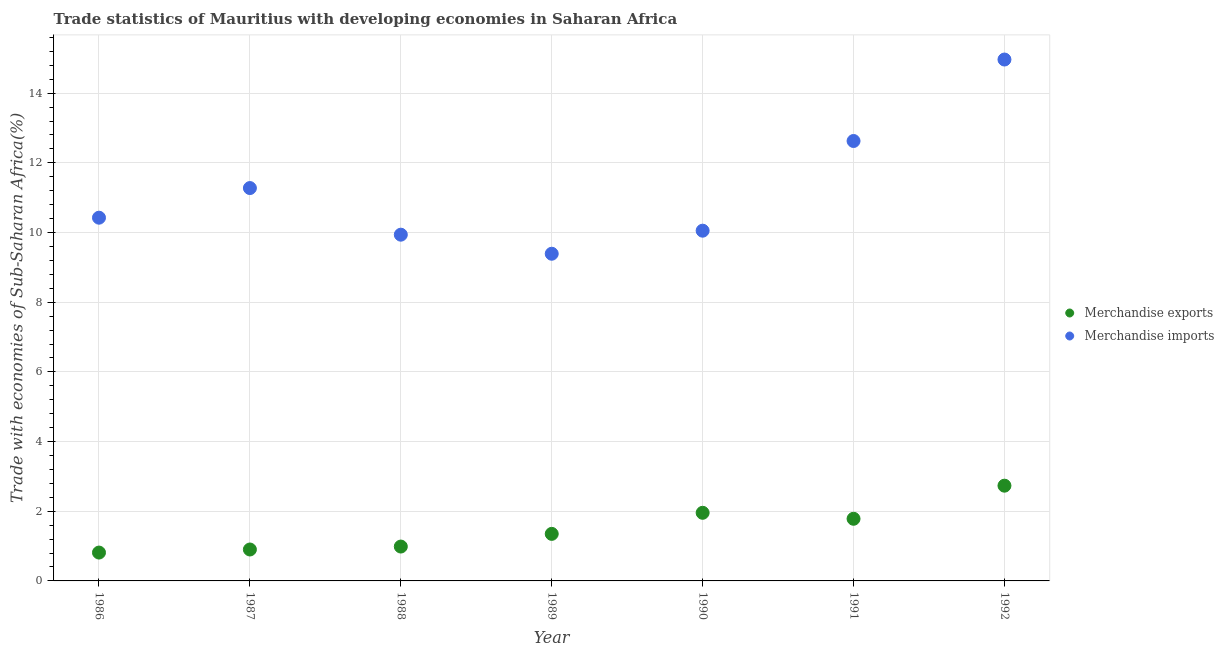How many different coloured dotlines are there?
Offer a very short reply. 2. What is the merchandise imports in 1990?
Ensure brevity in your answer.  10.05. Across all years, what is the maximum merchandise imports?
Offer a terse response. 14.97. Across all years, what is the minimum merchandise imports?
Make the answer very short. 9.39. In which year was the merchandise exports maximum?
Your answer should be very brief. 1992. What is the total merchandise imports in the graph?
Provide a succinct answer. 78.67. What is the difference between the merchandise exports in 1987 and that in 1992?
Offer a very short reply. -1.83. What is the difference between the merchandise exports in 1989 and the merchandise imports in 1990?
Keep it short and to the point. -8.7. What is the average merchandise imports per year?
Your answer should be very brief. 11.24. In the year 1992, what is the difference between the merchandise exports and merchandise imports?
Give a very brief answer. -12.23. In how many years, is the merchandise imports greater than 6 %?
Offer a terse response. 7. What is the ratio of the merchandise exports in 1986 to that in 1989?
Your answer should be very brief. 0.6. What is the difference between the highest and the second highest merchandise exports?
Provide a short and direct response. 0.78. What is the difference between the highest and the lowest merchandise exports?
Keep it short and to the point. 1.92. In how many years, is the merchandise imports greater than the average merchandise imports taken over all years?
Your answer should be very brief. 3. Is the sum of the merchandise exports in 1988 and 1989 greater than the maximum merchandise imports across all years?
Your answer should be compact. No. Does the merchandise exports monotonically increase over the years?
Make the answer very short. No. Is the merchandise exports strictly less than the merchandise imports over the years?
Make the answer very short. Yes. How many dotlines are there?
Your answer should be compact. 2. What is the difference between two consecutive major ticks on the Y-axis?
Your response must be concise. 2. Are the values on the major ticks of Y-axis written in scientific E-notation?
Provide a succinct answer. No. Where does the legend appear in the graph?
Your answer should be very brief. Center right. How are the legend labels stacked?
Keep it short and to the point. Vertical. What is the title of the graph?
Keep it short and to the point. Trade statistics of Mauritius with developing economies in Saharan Africa. Does "Age 15+" appear as one of the legend labels in the graph?
Your answer should be compact. No. What is the label or title of the Y-axis?
Your answer should be compact. Trade with economies of Sub-Saharan Africa(%). What is the Trade with economies of Sub-Saharan Africa(%) in Merchandise exports in 1986?
Provide a succinct answer. 0.81. What is the Trade with economies of Sub-Saharan Africa(%) in Merchandise imports in 1986?
Keep it short and to the point. 10.43. What is the Trade with economies of Sub-Saharan Africa(%) in Merchandise exports in 1987?
Your answer should be compact. 0.9. What is the Trade with economies of Sub-Saharan Africa(%) in Merchandise imports in 1987?
Your answer should be very brief. 11.28. What is the Trade with economies of Sub-Saharan Africa(%) in Merchandise exports in 1988?
Offer a terse response. 0.99. What is the Trade with economies of Sub-Saharan Africa(%) of Merchandise imports in 1988?
Your response must be concise. 9.94. What is the Trade with economies of Sub-Saharan Africa(%) in Merchandise exports in 1989?
Provide a succinct answer. 1.35. What is the Trade with economies of Sub-Saharan Africa(%) in Merchandise imports in 1989?
Your answer should be compact. 9.39. What is the Trade with economies of Sub-Saharan Africa(%) of Merchandise exports in 1990?
Your response must be concise. 1.96. What is the Trade with economies of Sub-Saharan Africa(%) of Merchandise imports in 1990?
Give a very brief answer. 10.05. What is the Trade with economies of Sub-Saharan Africa(%) of Merchandise exports in 1991?
Keep it short and to the point. 1.78. What is the Trade with economies of Sub-Saharan Africa(%) in Merchandise imports in 1991?
Your response must be concise. 12.63. What is the Trade with economies of Sub-Saharan Africa(%) in Merchandise exports in 1992?
Ensure brevity in your answer.  2.73. What is the Trade with economies of Sub-Saharan Africa(%) of Merchandise imports in 1992?
Your response must be concise. 14.97. Across all years, what is the maximum Trade with economies of Sub-Saharan Africa(%) of Merchandise exports?
Offer a very short reply. 2.73. Across all years, what is the maximum Trade with economies of Sub-Saharan Africa(%) of Merchandise imports?
Offer a very short reply. 14.97. Across all years, what is the minimum Trade with economies of Sub-Saharan Africa(%) in Merchandise exports?
Ensure brevity in your answer.  0.81. Across all years, what is the minimum Trade with economies of Sub-Saharan Africa(%) in Merchandise imports?
Ensure brevity in your answer.  9.39. What is the total Trade with economies of Sub-Saharan Africa(%) of Merchandise exports in the graph?
Keep it short and to the point. 10.52. What is the total Trade with economies of Sub-Saharan Africa(%) in Merchandise imports in the graph?
Provide a succinct answer. 78.67. What is the difference between the Trade with economies of Sub-Saharan Africa(%) of Merchandise exports in 1986 and that in 1987?
Your response must be concise. -0.09. What is the difference between the Trade with economies of Sub-Saharan Africa(%) of Merchandise imports in 1986 and that in 1987?
Your response must be concise. -0.85. What is the difference between the Trade with economies of Sub-Saharan Africa(%) of Merchandise exports in 1986 and that in 1988?
Provide a short and direct response. -0.17. What is the difference between the Trade with economies of Sub-Saharan Africa(%) in Merchandise imports in 1986 and that in 1988?
Provide a short and direct response. 0.49. What is the difference between the Trade with economies of Sub-Saharan Africa(%) in Merchandise exports in 1986 and that in 1989?
Provide a succinct answer. -0.54. What is the difference between the Trade with economies of Sub-Saharan Africa(%) in Merchandise imports in 1986 and that in 1989?
Offer a terse response. 1.03. What is the difference between the Trade with economies of Sub-Saharan Africa(%) of Merchandise exports in 1986 and that in 1990?
Your answer should be very brief. -1.14. What is the difference between the Trade with economies of Sub-Saharan Africa(%) of Merchandise imports in 1986 and that in 1990?
Keep it short and to the point. 0.37. What is the difference between the Trade with economies of Sub-Saharan Africa(%) in Merchandise exports in 1986 and that in 1991?
Ensure brevity in your answer.  -0.97. What is the difference between the Trade with economies of Sub-Saharan Africa(%) in Merchandise imports in 1986 and that in 1991?
Ensure brevity in your answer.  -2.2. What is the difference between the Trade with economies of Sub-Saharan Africa(%) in Merchandise exports in 1986 and that in 1992?
Give a very brief answer. -1.92. What is the difference between the Trade with economies of Sub-Saharan Africa(%) in Merchandise imports in 1986 and that in 1992?
Provide a succinct answer. -4.54. What is the difference between the Trade with economies of Sub-Saharan Africa(%) of Merchandise exports in 1987 and that in 1988?
Provide a succinct answer. -0.08. What is the difference between the Trade with economies of Sub-Saharan Africa(%) in Merchandise imports in 1987 and that in 1988?
Provide a short and direct response. 1.34. What is the difference between the Trade with economies of Sub-Saharan Africa(%) of Merchandise exports in 1987 and that in 1989?
Offer a very short reply. -0.45. What is the difference between the Trade with economies of Sub-Saharan Africa(%) of Merchandise imports in 1987 and that in 1989?
Offer a very short reply. 1.89. What is the difference between the Trade with economies of Sub-Saharan Africa(%) in Merchandise exports in 1987 and that in 1990?
Your response must be concise. -1.05. What is the difference between the Trade with economies of Sub-Saharan Africa(%) of Merchandise imports in 1987 and that in 1990?
Give a very brief answer. 1.22. What is the difference between the Trade with economies of Sub-Saharan Africa(%) in Merchandise exports in 1987 and that in 1991?
Provide a succinct answer. -0.88. What is the difference between the Trade with economies of Sub-Saharan Africa(%) in Merchandise imports in 1987 and that in 1991?
Give a very brief answer. -1.35. What is the difference between the Trade with economies of Sub-Saharan Africa(%) of Merchandise exports in 1987 and that in 1992?
Provide a succinct answer. -1.83. What is the difference between the Trade with economies of Sub-Saharan Africa(%) of Merchandise imports in 1987 and that in 1992?
Offer a very short reply. -3.69. What is the difference between the Trade with economies of Sub-Saharan Africa(%) of Merchandise exports in 1988 and that in 1989?
Provide a short and direct response. -0.36. What is the difference between the Trade with economies of Sub-Saharan Africa(%) in Merchandise imports in 1988 and that in 1989?
Provide a short and direct response. 0.55. What is the difference between the Trade with economies of Sub-Saharan Africa(%) in Merchandise exports in 1988 and that in 1990?
Your answer should be very brief. -0.97. What is the difference between the Trade with economies of Sub-Saharan Africa(%) in Merchandise imports in 1988 and that in 1990?
Your answer should be very brief. -0.11. What is the difference between the Trade with economies of Sub-Saharan Africa(%) in Merchandise exports in 1988 and that in 1991?
Your response must be concise. -0.8. What is the difference between the Trade with economies of Sub-Saharan Africa(%) of Merchandise imports in 1988 and that in 1991?
Offer a terse response. -2.69. What is the difference between the Trade with economies of Sub-Saharan Africa(%) in Merchandise exports in 1988 and that in 1992?
Ensure brevity in your answer.  -1.75. What is the difference between the Trade with economies of Sub-Saharan Africa(%) of Merchandise imports in 1988 and that in 1992?
Offer a terse response. -5.03. What is the difference between the Trade with economies of Sub-Saharan Africa(%) of Merchandise exports in 1989 and that in 1990?
Offer a very short reply. -0.6. What is the difference between the Trade with economies of Sub-Saharan Africa(%) in Merchandise imports in 1989 and that in 1990?
Offer a terse response. -0.66. What is the difference between the Trade with economies of Sub-Saharan Africa(%) in Merchandise exports in 1989 and that in 1991?
Provide a succinct answer. -0.43. What is the difference between the Trade with economies of Sub-Saharan Africa(%) of Merchandise imports in 1989 and that in 1991?
Keep it short and to the point. -3.24. What is the difference between the Trade with economies of Sub-Saharan Africa(%) of Merchandise exports in 1989 and that in 1992?
Your answer should be compact. -1.38. What is the difference between the Trade with economies of Sub-Saharan Africa(%) of Merchandise imports in 1989 and that in 1992?
Make the answer very short. -5.57. What is the difference between the Trade with economies of Sub-Saharan Africa(%) of Merchandise exports in 1990 and that in 1991?
Ensure brevity in your answer.  0.17. What is the difference between the Trade with economies of Sub-Saharan Africa(%) in Merchandise imports in 1990 and that in 1991?
Give a very brief answer. -2.57. What is the difference between the Trade with economies of Sub-Saharan Africa(%) in Merchandise exports in 1990 and that in 1992?
Offer a terse response. -0.78. What is the difference between the Trade with economies of Sub-Saharan Africa(%) of Merchandise imports in 1990 and that in 1992?
Your answer should be very brief. -4.91. What is the difference between the Trade with economies of Sub-Saharan Africa(%) of Merchandise exports in 1991 and that in 1992?
Your answer should be very brief. -0.95. What is the difference between the Trade with economies of Sub-Saharan Africa(%) of Merchandise imports in 1991 and that in 1992?
Provide a short and direct response. -2.34. What is the difference between the Trade with economies of Sub-Saharan Africa(%) in Merchandise exports in 1986 and the Trade with economies of Sub-Saharan Africa(%) in Merchandise imports in 1987?
Your response must be concise. -10.46. What is the difference between the Trade with economies of Sub-Saharan Africa(%) in Merchandise exports in 1986 and the Trade with economies of Sub-Saharan Africa(%) in Merchandise imports in 1988?
Your response must be concise. -9.12. What is the difference between the Trade with economies of Sub-Saharan Africa(%) in Merchandise exports in 1986 and the Trade with economies of Sub-Saharan Africa(%) in Merchandise imports in 1989?
Provide a succinct answer. -8.58. What is the difference between the Trade with economies of Sub-Saharan Africa(%) in Merchandise exports in 1986 and the Trade with economies of Sub-Saharan Africa(%) in Merchandise imports in 1990?
Your answer should be compact. -9.24. What is the difference between the Trade with economies of Sub-Saharan Africa(%) of Merchandise exports in 1986 and the Trade with economies of Sub-Saharan Africa(%) of Merchandise imports in 1991?
Your answer should be very brief. -11.81. What is the difference between the Trade with economies of Sub-Saharan Africa(%) of Merchandise exports in 1986 and the Trade with economies of Sub-Saharan Africa(%) of Merchandise imports in 1992?
Keep it short and to the point. -14.15. What is the difference between the Trade with economies of Sub-Saharan Africa(%) of Merchandise exports in 1987 and the Trade with economies of Sub-Saharan Africa(%) of Merchandise imports in 1988?
Your response must be concise. -9.04. What is the difference between the Trade with economies of Sub-Saharan Africa(%) of Merchandise exports in 1987 and the Trade with economies of Sub-Saharan Africa(%) of Merchandise imports in 1989?
Offer a terse response. -8.49. What is the difference between the Trade with economies of Sub-Saharan Africa(%) in Merchandise exports in 1987 and the Trade with economies of Sub-Saharan Africa(%) in Merchandise imports in 1990?
Provide a succinct answer. -9.15. What is the difference between the Trade with economies of Sub-Saharan Africa(%) in Merchandise exports in 1987 and the Trade with economies of Sub-Saharan Africa(%) in Merchandise imports in 1991?
Offer a terse response. -11.72. What is the difference between the Trade with economies of Sub-Saharan Africa(%) in Merchandise exports in 1987 and the Trade with economies of Sub-Saharan Africa(%) in Merchandise imports in 1992?
Your response must be concise. -14.06. What is the difference between the Trade with economies of Sub-Saharan Africa(%) of Merchandise exports in 1988 and the Trade with economies of Sub-Saharan Africa(%) of Merchandise imports in 1989?
Give a very brief answer. -8.4. What is the difference between the Trade with economies of Sub-Saharan Africa(%) of Merchandise exports in 1988 and the Trade with economies of Sub-Saharan Africa(%) of Merchandise imports in 1990?
Make the answer very short. -9.07. What is the difference between the Trade with economies of Sub-Saharan Africa(%) of Merchandise exports in 1988 and the Trade with economies of Sub-Saharan Africa(%) of Merchandise imports in 1991?
Ensure brevity in your answer.  -11.64. What is the difference between the Trade with economies of Sub-Saharan Africa(%) in Merchandise exports in 1988 and the Trade with economies of Sub-Saharan Africa(%) in Merchandise imports in 1992?
Your answer should be very brief. -13.98. What is the difference between the Trade with economies of Sub-Saharan Africa(%) in Merchandise exports in 1989 and the Trade with economies of Sub-Saharan Africa(%) in Merchandise imports in 1990?
Ensure brevity in your answer.  -8.7. What is the difference between the Trade with economies of Sub-Saharan Africa(%) of Merchandise exports in 1989 and the Trade with economies of Sub-Saharan Africa(%) of Merchandise imports in 1991?
Provide a short and direct response. -11.28. What is the difference between the Trade with economies of Sub-Saharan Africa(%) in Merchandise exports in 1989 and the Trade with economies of Sub-Saharan Africa(%) in Merchandise imports in 1992?
Keep it short and to the point. -13.61. What is the difference between the Trade with economies of Sub-Saharan Africa(%) in Merchandise exports in 1990 and the Trade with economies of Sub-Saharan Africa(%) in Merchandise imports in 1991?
Provide a succinct answer. -10.67. What is the difference between the Trade with economies of Sub-Saharan Africa(%) of Merchandise exports in 1990 and the Trade with economies of Sub-Saharan Africa(%) of Merchandise imports in 1992?
Ensure brevity in your answer.  -13.01. What is the difference between the Trade with economies of Sub-Saharan Africa(%) in Merchandise exports in 1991 and the Trade with economies of Sub-Saharan Africa(%) in Merchandise imports in 1992?
Ensure brevity in your answer.  -13.18. What is the average Trade with economies of Sub-Saharan Africa(%) of Merchandise exports per year?
Provide a succinct answer. 1.5. What is the average Trade with economies of Sub-Saharan Africa(%) of Merchandise imports per year?
Give a very brief answer. 11.24. In the year 1986, what is the difference between the Trade with economies of Sub-Saharan Africa(%) of Merchandise exports and Trade with economies of Sub-Saharan Africa(%) of Merchandise imports?
Make the answer very short. -9.61. In the year 1987, what is the difference between the Trade with economies of Sub-Saharan Africa(%) in Merchandise exports and Trade with economies of Sub-Saharan Africa(%) in Merchandise imports?
Your answer should be compact. -10.37. In the year 1988, what is the difference between the Trade with economies of Sub-Saharan Africa(%) in Merchandise exports and Trade with economies of Sub-Saharan Africa(%) in Merchandise imports?
Offer a terse response. -8.95. In the year 1989, what is the difference between the Trade with economies of Sub-Saharan Africa(%) in Merchandise exports and Trade with economies of Sub-Saharan Africa(%) in Merchandise imports?
Make the answer very short. -8.04. In the year 1990, what is the difference between the Trade with economies of Sub-Saharan Africa(%) of Merchandise exports and Trade with economies of Sub-Saharan Africa(%) of Merchandise imports?
Give a very brief answer. -8.1. In the year 1991, what is the difference between the Trade with economies of Sub-Saharan Africa(%) of Merchandise exports and Trade with economies of Sub-Saharan Africa(%) of Merchandise imports?
Keep it short and to the point. -10.84. In the year 1992, what is the difference between the Trade with economies of Sub-Saharan Africa(%) of Merchandise exports and Trade with economies of Sub-Saharan Africa(%) of Merchandise imports?
Offer a terse response. -12.23. What is the ratio of the Trade with economies of Sub-Saharan Africa(%) in Merchandise exports in 1986 to that in 1987?
Your response must be concise. 0.9. What is the ratio of the Trade with economies of Sub-Saharan Africa(%) in Merchandise imports in 1986 to that in 1987?
Provide a short and direct response. 0.92. What is the ratio of the Trade with economies of Sub-Saharan Africa(%) in Merchandise exports in 1986 to that in 1988?
Keep it short and to the point. 0.83. What is the ratio of the Trade with economies of Sub-Saharan Africa(%) in Merchandise imports in 1986 to that in 1988?
Ensure brevity in your answer.  1.05. What is the ratio of the Trade with economies of Sub-Saharan Africa(%) of Merchandise exports in 1986 to that in 1989?
Provide a succinct answer. 0.6. What is the ratio of the Trade with economies of Sub-Saharan Africa(%) of Merchandise imports in 1986 to that in 1989?
Make the answer very short. 1.11. What is the ratio of the Trade with economies of Sub-Saharan Africa(%) in Merchandise exports in 1986 to that in 1990?
Give a very brief answer. 0.42. What is the ratio of the Trade with economies of Sub-Saharan Africa(%) in Merchandise imports in 1986 to that in 1990?
Offer a terse response. 1.04. What is the ratio of the Trade with economies of Sub-Saharan Africa(%) in Merchandise exports in 1986 to that in 1991?
Keep it short and to the point. 0.46. What is the ratio of the Trade with economies of Sub-Saharan Africa(%) of Merchandise imports in 1986 to that in 1991?
Make the answer very short. 0.83. What is the ratio of the Trade with economies of Sub-Saharan Africa(%) in Merchandise exports in 1986 to that in 1992?
Your answer should be compact. 0.3. What is the ratio of the Trade with economies of Sub-Saharan Africa(%) of Merchandise imports in 1986 to that in 1992?
Ensure brevity in your answer.  0.7. What is the ratio of the Trade with economies of Sub-Saharan Africa(%) of Merchandise exports in 1987 to that in 1988?
Your answer should be very brief. 0.91. What is the ratio of the Trade with economies of Sub-Saharan Africa(%) in Merchandise imports in 1987 to that in 1988?
Ensure brevity in your answer.  1.13. What is the ratio of the Trade with economies of Sub-Saharan Africa(%) in Merchandise exports in 1987 to that in 1989?
Give a very brief answer. 0.67. What is the ratio of the Trade with economies of Sub-Saharan Africa(%) of Merchandise imports in 1987 to that in 1989?
Make the answer very short. 1.2. What is the ratio of the Trade with economies of Sub-Saharan Africa(%) of Merchandise exports in 1987 to that in 1990?
Make the answer very short. 0.46. What is the ratio of the Trade with economies of Sub-Saharan Africa(%) of Merchandise imports in 1987 to that in 1990?
Your response must be concise. 1.12. What is the ratio of the Trade with economies of Sub-Saharan Africa(%) of Merchandise exports in 1987 to that in 1991?
Your answer should be compact. 0.51. What is the ratio of the Trade with economies of Sub-Saharan Africa(%) of Merchandise imports in 1987 to that in 1991?
Offer a very short reply. 0.89. What is the ratio of the Trade with economies of Sub-Saharan Africa(%) of Merchandise exports in 1987 to that in 1992?
Ensure brevity in your answer.  0.33. What is the ratio of the Trade with economies of Sub-Saharan Africa(%) in Merchandise imports in 1987 to that in 1992?
Provide a short and direct response. 0.75. What is the ratio of the Trade with economies of Sub-Saharan Africa(%) of Merchandise exports in 1988 to that in 1989?
Ensure brevity in your answer.  0.73. What is the ratio of the Trade with economies of Sub-Saharan Africa(%) of Merchandise imports in 1988 to that in 1989?
Your response must be concise. 1.06. What is the ratio of the Trade with economies of Sub-Saharan Africa(%) in Merchandise exports in 1988 to that in 1990?
Provide a succinct answer. 0.5. What is the ratio of the Trade with economies of Sub-Saharan Africa(%) of Merchandise imports in 1988 to that in 1990?
Provide a succinct answer. 0.99. What is the ratio of the Trade with economies of Sub-Saharan Africa(%) of Merchandise exports in 1988 to that in 1991?
Provide a succinct answer. 0.55. What is the ratio of the Trade with economies of Sub-Saharan Africa(%) in Merchandise imports in 1988 to that in 1991?
Your response must be concise. 0.79. What is the ratio of the Trade with economies of Sub-Saharan Africa(%) of Merchandise exports in 1988 to that in 1992?
Offer a terse response. 0.36. What is the ratio of the Trade with economies of Sub-Saharan Africa(%) of Merchandise imports in 1988 to that in 1992?
Your answer should be compact. 0.66. What is the ratio of the Trade with economies of Sub-Saharan Africa(%) in Merchandise exports in 1989 to that in 1990?
Offer a terse response. 0.69. What is the ratio of the Trade with economies of Sub-Saharan Africa(%) in Merchandise imports in 1989 to that in 1990?
Your response must be concise. 0.93. What is the ratio of the Trade with economies of Sub-Saharan Africa(%) in Merchandise exports in 1989 to that in 1991?
Your answer should be very brief. 0.76. What is the ratio of the Trade with economies of Sub-Saharan Africa(%) in Merchandise imports in 1989 to that in 1991?
Make the answer very short. 0.74. What is the ratio of the Trade with economies of Sub-Saharan Africa(%) in Merchandise exports in 1989 to that in 1992?
Your response must be concise. 0.49. What is the ratio of the Trade with economies of Sub-Saharan Africa(%) of Merchandise imports in 1989 to that in 1992?
Keep it short and to the point. 0.63. What is the ratio of the Trade with economies of Sub-Saharan Africa(%) of Merchandise exports in 1990 to that in 1991?
Make the answer very short. 1.1. What is the ratio of the Trade with economies of Sub-Saharan Africa(%) in Merchandise imports in 1990 to that in 1991?
Offer a very short reply. 0.8. What is the ratio of the Trade with economies of Sub-Saharan Africa(%) in Merchandise exports in 1990 to that in 1992?
Your answer should be compact. 0.72. What is the ratio of the Trade with economies of Sub-Saharan Africa(%) of Merchandise imports in 1990 to that in 1992?
Keep it short and to the point. 0.67. What is the ratio of the Trade with economies of Sub-Saharan Africa(%) of Merchandise exports in 1991 to that in 1992?
Your answer should be very brief. 0.65. What is the ratio of the Trade with economies of Sub-Saharan Africa(%) in Merchandise imports in 1991 to that in 1992?
Provide a short and direct response. 0.84. What is the difference between the highest and the second highest Trade with economies of Sub-Saharan Africa(%) in Merchandise exports?
Offer a very short reply. 0.78. What is the difference between the highest and the second highest Trade with economies of Sub-Saharan Africa(%) of Merchandise imports?
Provide a short and direct response. 2.34. What is the difference between the highest and the lowest Trade with economies of Sub-Saharan Africa(%) in Merchandise exports?
Provide a succinct answer. 1.92. What is the difference between the highest and the lowest Trade with economies of Sub-Saharan Africa(%) of Merchandise imports?
Your answer should be compact. 5.57. 